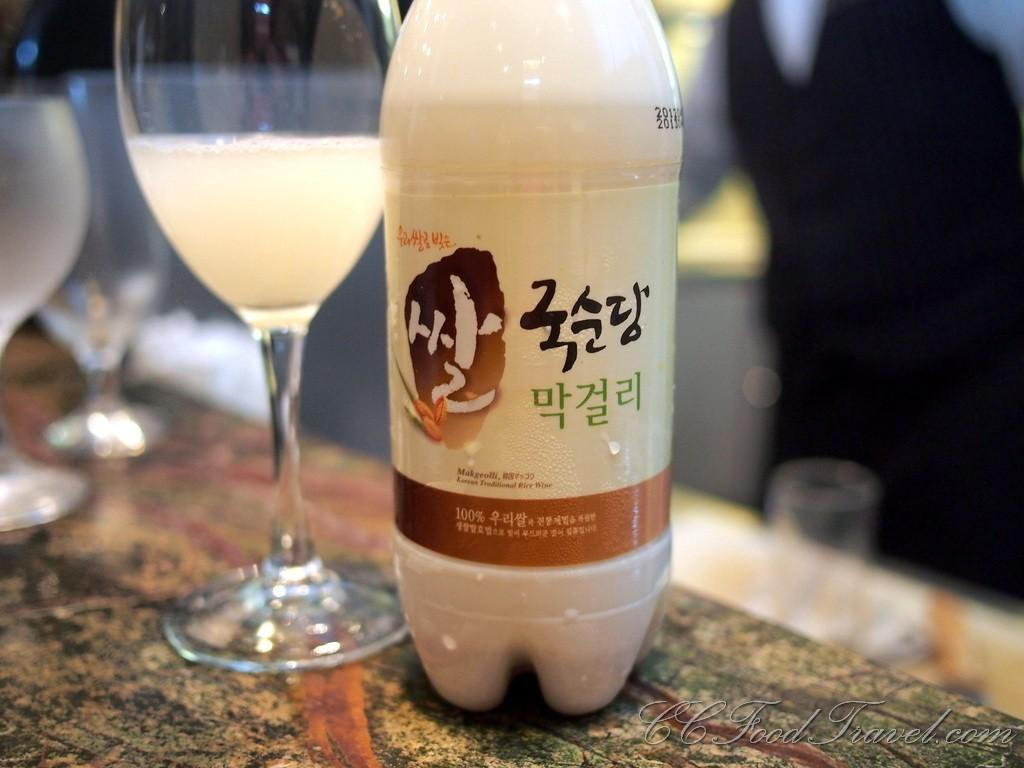What objects are on the table in the image? There are glasses and a bottle on the table in the image. What is the bottle containing? The information provided does not specify the contents of the bottle. Can you describe the bottle's appearance? The bottle has a logo on it. How many dolls are sitting on the wing in the image? There are no dolls or wings present in the image. 